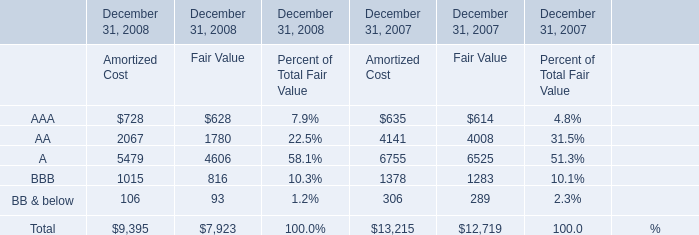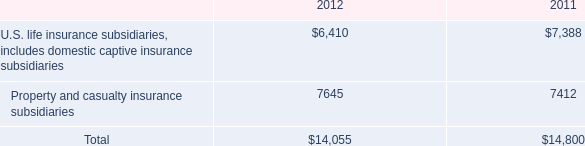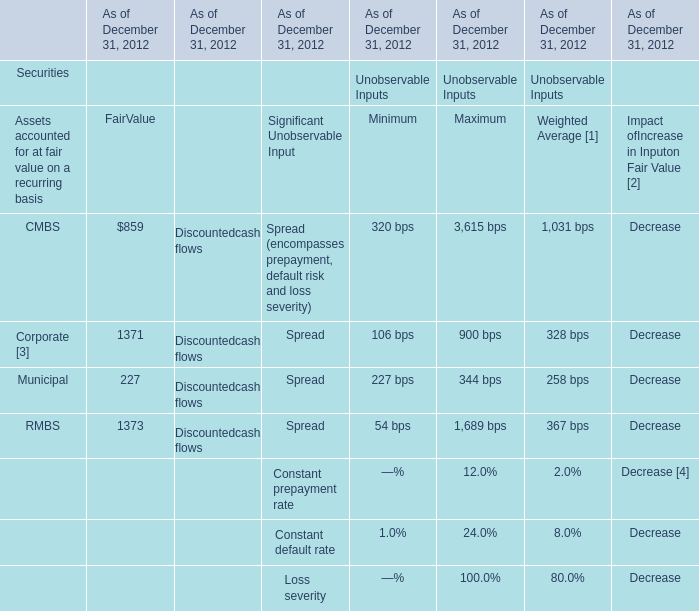What is the average amount of Property and casualty insurance subsidiaries of 2012, and A of December 31, 2008 Fair Value ? 
Computations: ((7645.0 + 4606.0) / 2)
Answer: 6125.5. 